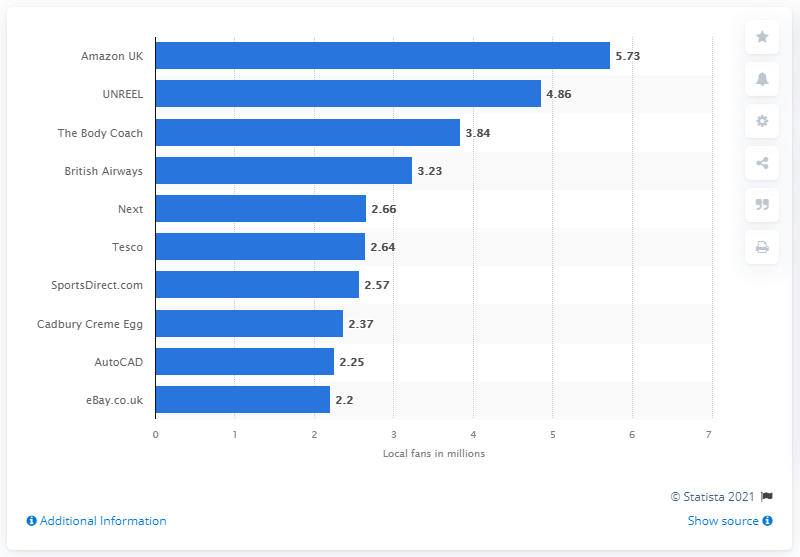Highlight a few significant elements in this photo. In March of 2020, UNREEL had 4,860 fans. As of March 2020, Amazon UK had 5.73 local fans. 